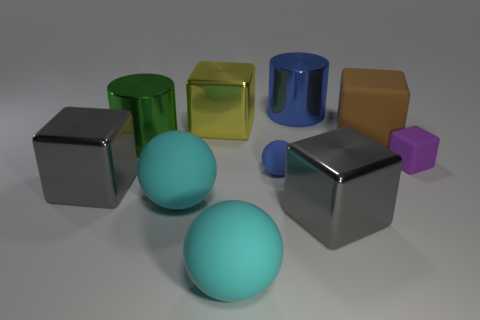Subtract all purple blocks. How many blocks are left? 4 Subtract all big yellow metallic cubes. How many cubes are left? 4 Subtract all yellow cubes. Subtract all red cylinders. How many cubes are left? 4 Subtract all cylinders. How many objects are left? 8 Subtract all big red rubber cylinders. Subtract all large cyan spheres. How many objects are left? 8 Add 8 blue objects. How many blue objects are left? 10 Add 1 blocks. How many blocks exist? 6 Subtract 1 cyan balls. How many objects are left? 9 